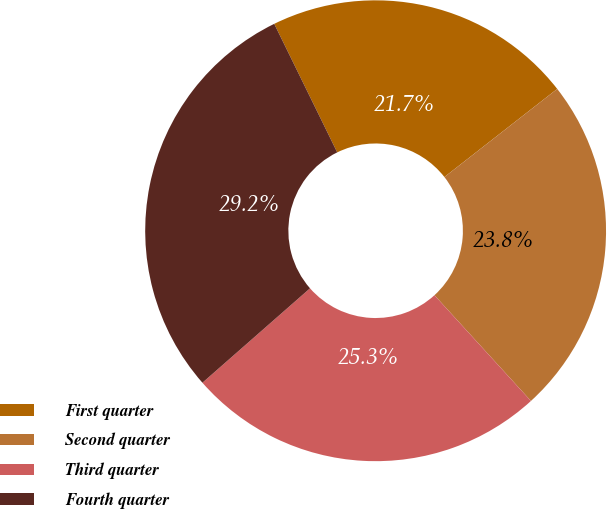Convert chart to OTSL. <chart><loc_0><loc_0><loc_500><loc_500><pie_chart><fcel>First quarter<fcel>Second quarter<fcel>Third quarter<fcel>Fourth quarter<nl><fcel>21.7%<fcel>23.78%<fcel>25.31%<fcel>29.21%<nl></chart> 